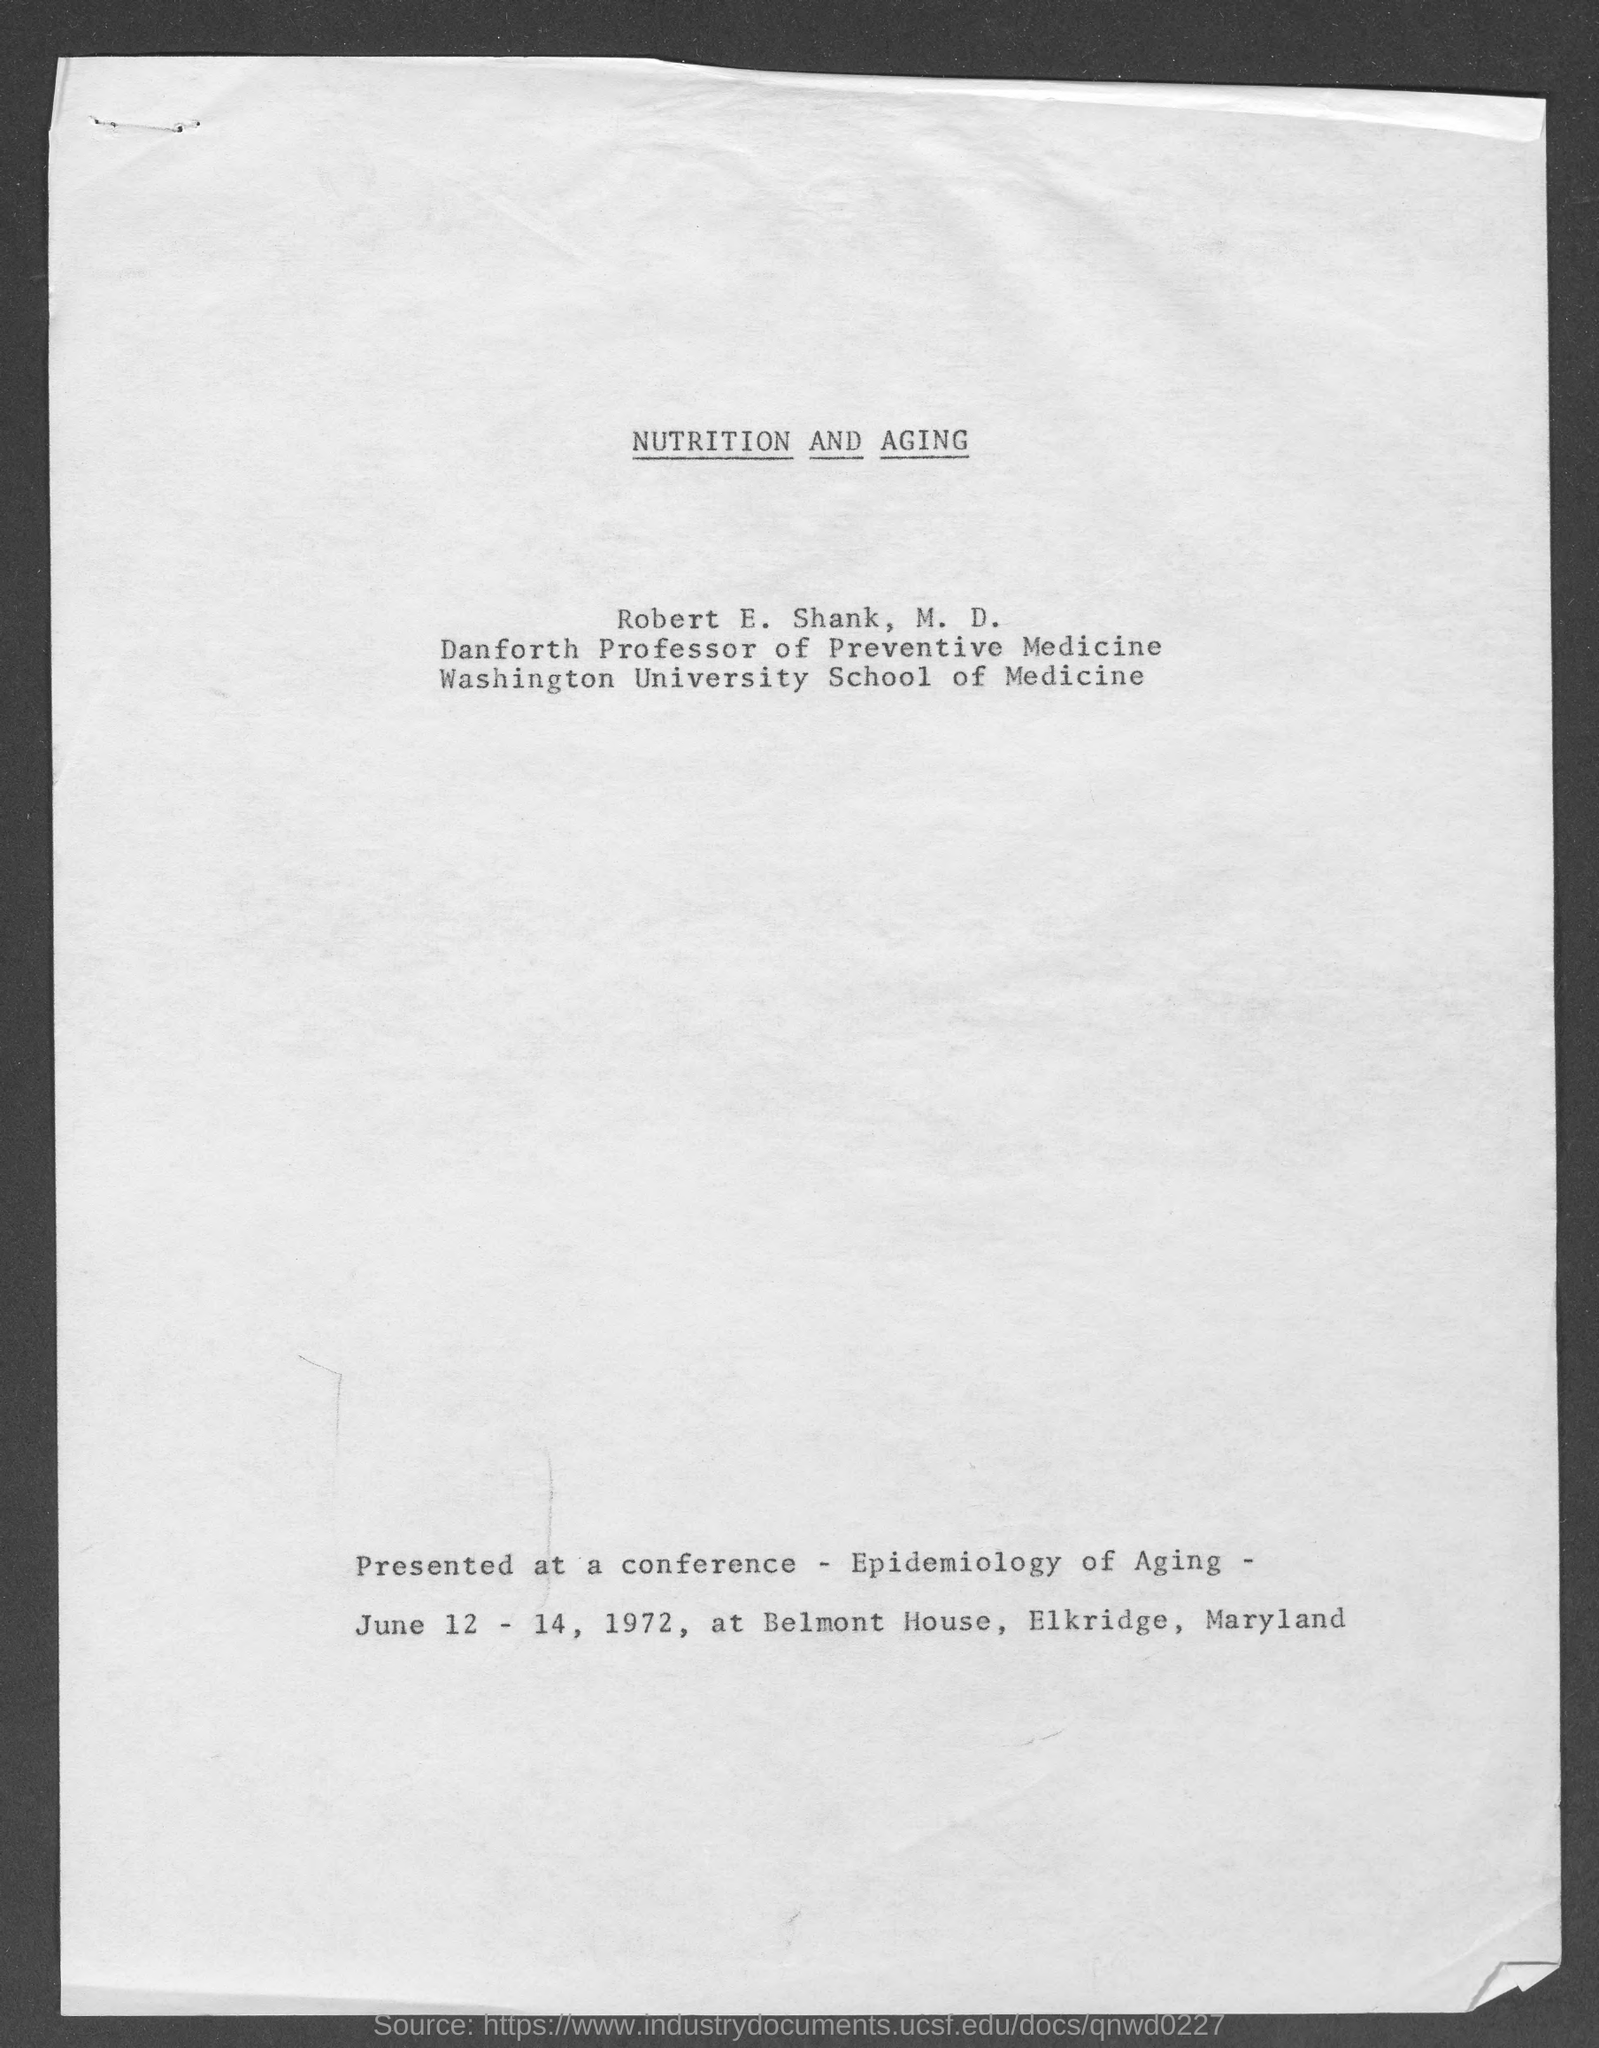What is the designation of Robert E. Shank,  M. D.?
Your response must be concise. Danforth Professor of Preventive Medicine. 